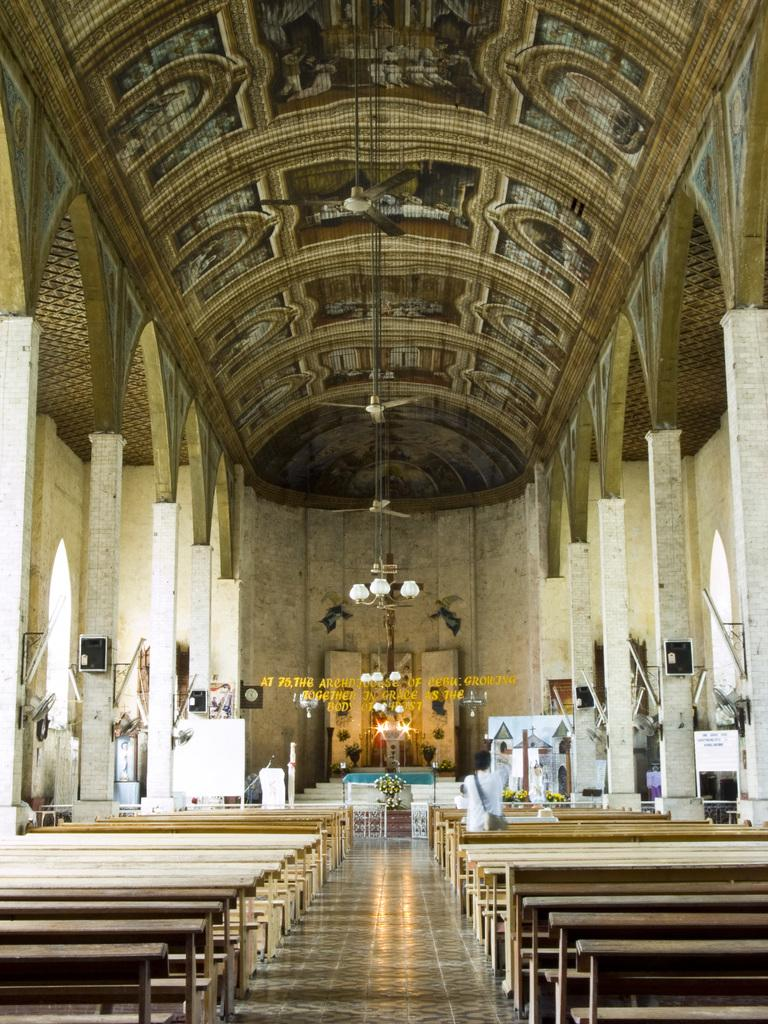What type of furniture can be seen at the bottom of the picture? There are benches in the bottom of the picture. What is hanging in the middle of the picture? There is a chandelier hanging in the middle of the picture. What can be seen in the background of the picture? There is a wall visible in the background of the picture. How many cherries are hanging from the chandelier in the picture? There are no cherries present in the image; the chandelier is the only object hanging in the middle of the picture. What type of form or wing can be seen on the benches in the picture? The benches in the picture do not have any forms or wings; they are simple furniture pieces. 